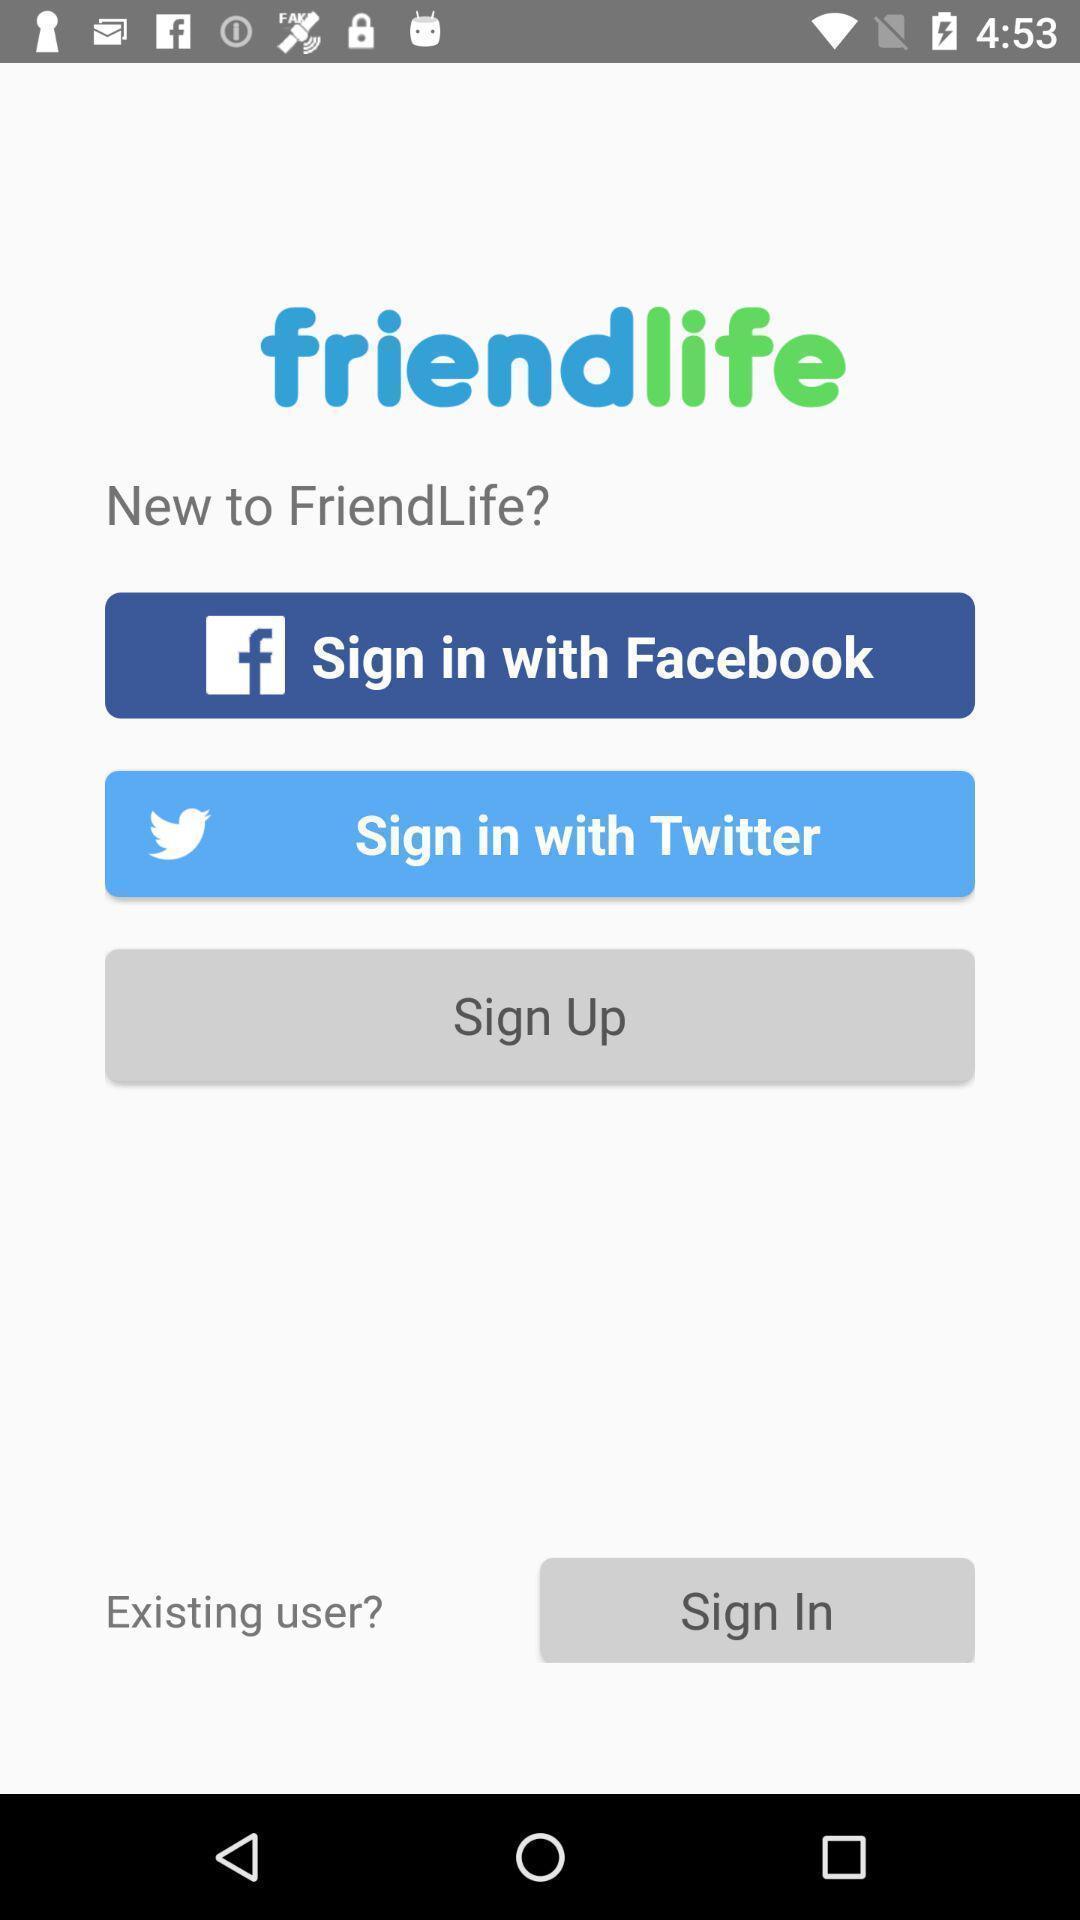Explain what's happening in this screen capture. Welcome to the login page. 